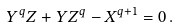<formula> <loc_0><loc_0><loc_500><loc_500>Y ^ { q } Z + Y Z ^ { q } - X ^ { q + 1 } = 0 \, .</formula> 